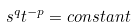Convert formula to latex. <formula><loc_0><loc_0><loc_500><loc_500>s ^ { q } t ^ { - p } = c o n s t a n t</formula> 